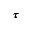Convert formula to latex. <formula><loc_0><loc_0><loc_500><loc_500>\pm b { \tau }</formula> 